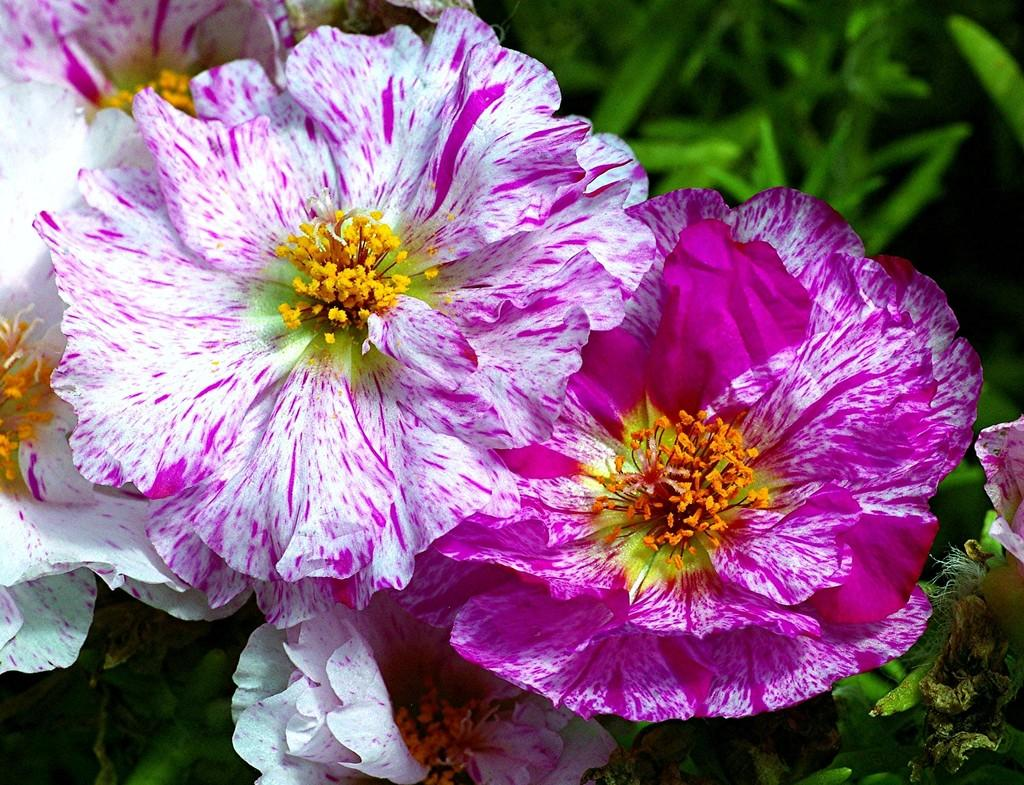What is the main subject in the center of the image? There are flowers in the center of the image. What other type of vegetation can be seen in the image? There are plants in the top side of the image. What type of church can be seen in the image? There is no church present in the image; it features flowers and plants. What kind of string is used to hold the flowers together in the image? There is no string visible in the image, as the flowers are not held together by any visible means. 